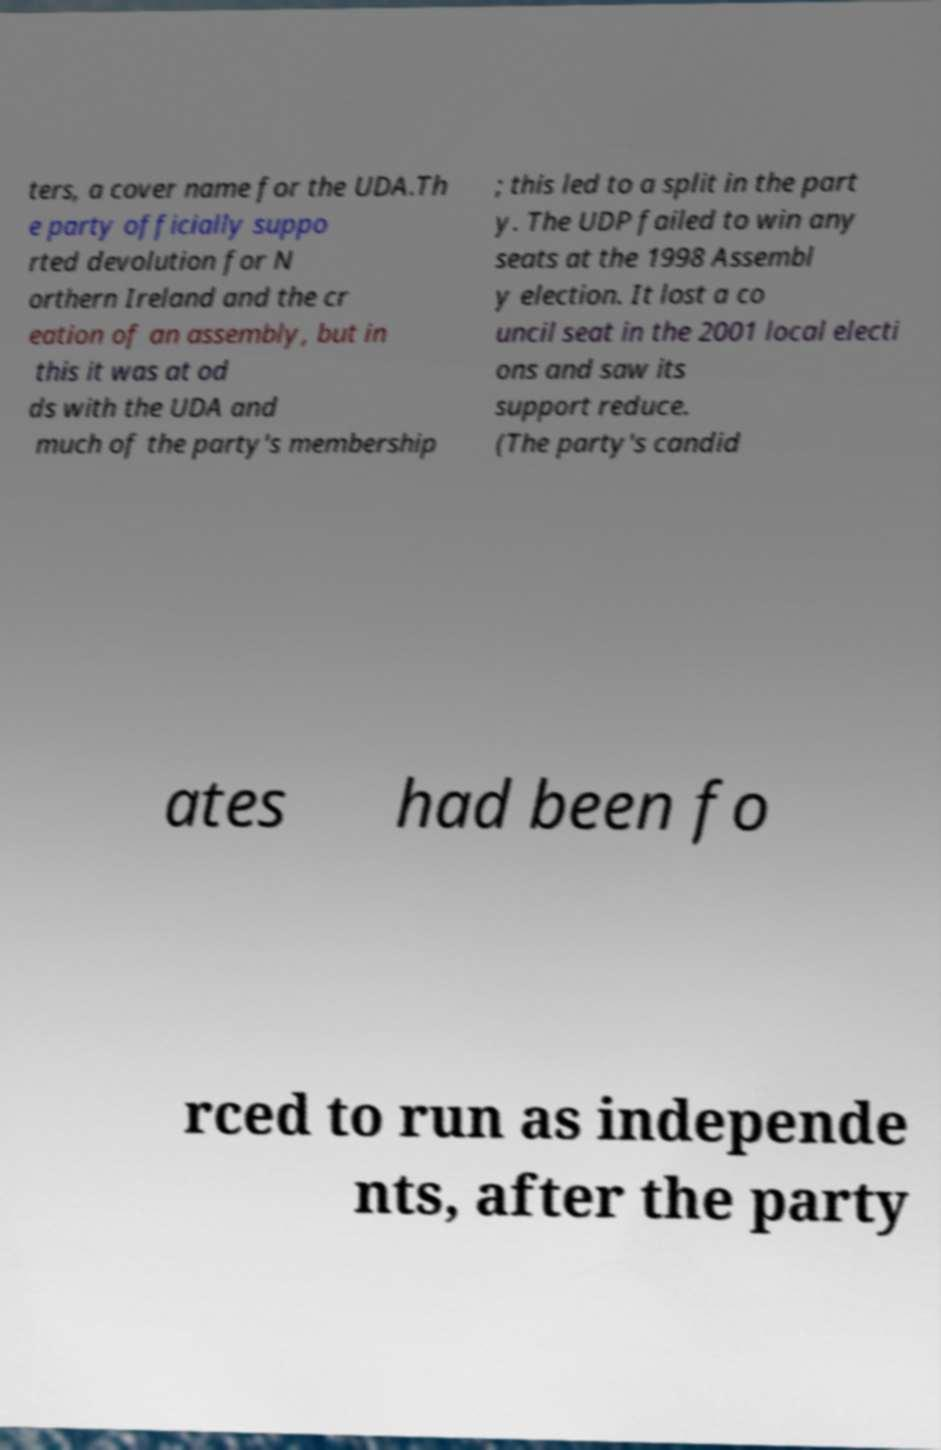Could you assist in decoding the text presented in this image and type it out clearly? ters, a cover name for the UDA.Th e party officially suppo rted devolution for N orthern Ireland and the cr eation of an assembly, but in this it was at od ds with the UDA and much of the party's membership ; this led to a split in the part y. The UDP failed to win any seats at the 1998 Assembl y election. It lost a co uncil seat in the 2001 local electi ons and saw its support reduce. (The party's candid ates had been fo rced to run as independe nts, after the party 